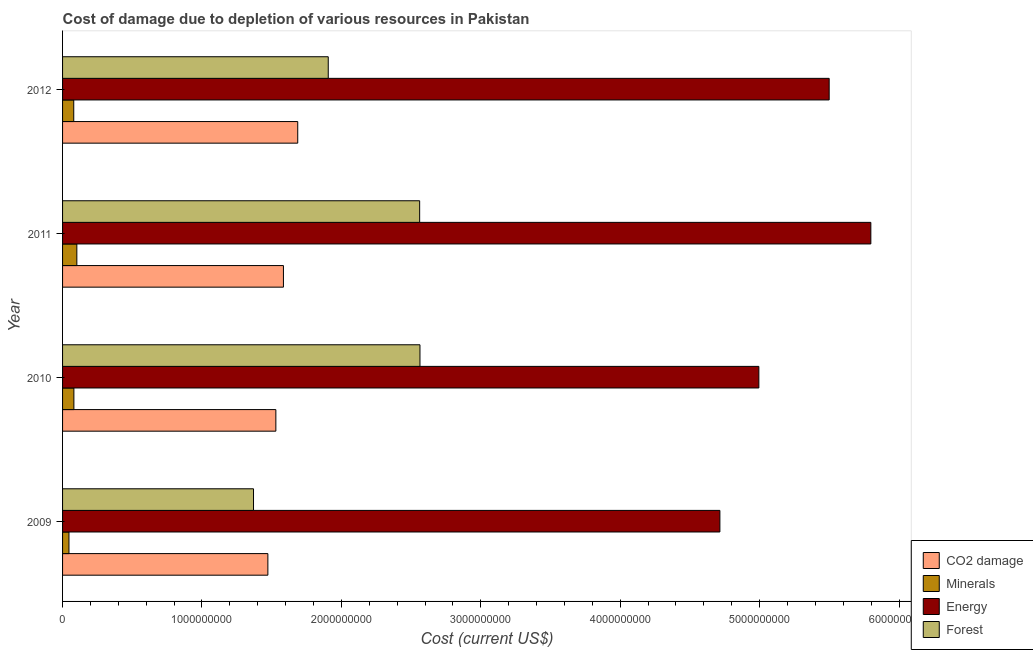How many different coloured bars are there?
Make the answer very short. 4. How many groups of bars are there?
Offer a terse response. 4. Are the number of bars on each tick of the Y-axis equal?
Your answer should be compact. Yes. How many bars are there on the 1st tick from the bottom?
Your response must be concise. 4. What is the label of the 3rd group of bars from the top?
Offer a terse response. 2010. What is the cost of damage due to depletion of energy in 2011?
Offer a terse response. 5.80e+09. Across all years, what is the maximum cost of damage due to depletion of coal?
Offer a very short reply. 1.69e+09. Across all years, what is the minimum cost of damage due to depletion of coal?
Offer a very short reply. 1.47e+09. In which year was the cost of damage due to depletion of forests maximum?
Give a very brief answer. 2010. In which year was the cost of damage due to depletion of forests minimum?
Keep it short and to the point. 2009. What is the total cost of damage due to depletion of energy in the graph?
Your answer should be compact. 2.10e+1. What is the difference between the cost of damage due to depletion of energy in 2009 and that in 2012?
Offer a very short reply. -7.84e+08. What is the difference between the cost of damage due to depletion of minerals in 2012 and the cost of damage due to depletion of energy in 2011?
Your response must be concise. -5.72e+09. What is the average cost of damage due to depletion of energy per year?
Your answer should be very brief. 5.25e+09. In the year 2009, what is the difference between the cost of damage due to depletion of forests and cost of damage due to depletion of minerals?
Provide a succinct answer. 1.32e+09. In how many years, is the cost of damage due to depletion of coal greater than 2400000000 US$?
Keep it short and to the point. 0. What is the ratio of the cost of damage due to depletion of forests in 2009 to that in 2010?
Your response must be concise. 0.53. What is the difference between the highest and the second highest cost of damage due to depletion of forests?
Your response must be concise. 2.16e+06. What is the difference between the highest and the lowest cost of damage due to depletion of coal?
Provide a succinct answer. 2.14e+08. In how many years, is the cost of damage due to depletion of minerals greater than the average cost of damage due to depletion of minerals taken over all years?
Your answer should be compact. 3. What does the 4th bar from the top in 2012 represents?
Your response must be concise. CO2 damage. What does the 4th bar from the bottom in 2012 represents?
Offer a very short reply. Forest. Is it the case that in every year, the sum of the cost of damage due to depletion of coal and cost of damage due to depletion of minerals is greater than the cost of damage due to depletion of energy?
Your response must be concise. No. What is the difference between two consecutive major ticks on the X-axis?
Ensure brevity in your answer.  1.00e+09. Are the values on the major ticks of X-axis written in scientific E-notation?
Give a very brief answer. No. Does the graph contain grids?
Give a very brief answer. No. Where does the legend appear in the graph?
Ensure brevity in your answer.  Bottom right. How many legend labels are there?
Provide a succinct answer. 4. What is the title of the graph?
Keep it short and to the point. Cost of damage due to depletion of various resources in Pakistan . Does "Australia" appear as one of the legend labels in the graph?
Offer a very short reply. No. What is the label or title of the X-axis?
Offer a terse response. Cost (current US$). What is the label or title of the Y-axis?
Offer a very short reply. Year. What is the Cost (current US$) of CO2 damage in 2009?
Give a very brief answer. 1.47e+09. What is the Cost (current US$) in Minerals in 2009?
Give a very brief answer. 4.59e+07. What is the Cost (current US$) of Energy in 2009?
Your answer should be compact. 4.72e+09. What is the Cost (current US$) of Forest in 2009?
Your response must be concise. 1.37e+09. What is the Cost (current US$) of CO2 damage in 2010?
Keep it short and to the point. 1.53e+09. What is the Cost (current US$) in Minerals in 2010?
Your response must be concise. 8.13e+07. What is the Cost (current US$) in Energy in 2010?
Your answer should be very brief. 4.99e+09. What is the Cost (current US$) of Forest in 2010?
Provide a succinct answer. 2.56e+09. What is the Cost (current US$) of CO2 damage in 2011?
Offer a very short reply. 1.58e+09. What is the Cost (current US$) in Minerals in 2011?
Provide a succinct answer. 1.02e+08. What is the Cost (current US$) of Energy in 2011?
Your answer should be very brief. 5.80e+09. What is the Cost (current US$) of Forest in 2011?
Keep it short and to the point. 2.56e+09. What is the Cost (current US$) of CO2 damage in 2012?
Ensure brevity in your answer.  1.69e+09. What is the Cost (current US$) of Minerals in 2012?
Give a very brief answer. 8.02e+07. What is the Cost (current US$) of Energy in 2012?
Ensure brevity in your answer.  5.50e+09. What is the Cost (current US$) in Forest in 2012?
Your answer should be compact. 1.91e+09. Across all years, what is the maximum Cost (current US$) in CO2 damage?
Your answer should be compact. 1.69e+09. Across all years, what is the maximum Cost (current US$) in Minerals?
Your response must be concise. 1.02e+08. Across all years, what is the maximum Cost (current US$) in Energy?
Ensure brevity in your answer.  5.80e+09. Across all years, what is the maximum Cost (current US$) of Forest?
Provide a short and direct response. 2.56e+09. Across all years, what is the minimum Cost (current US$) of CO2 damage?
Give a very brief answer. 1.47e+09. Across all years, what is the minimum Cost (current US$) of Minerals?
Provide a succinct answer. 4.59e+07. Across all years, what is the minimum Cost (current US$) of Energy?
Offer a terse response. 4.72e+09. Across all years, what is the minimum Cost (current US$) of Forest?
Provide a succinct answer. 1.37e+09. What is the total Cost (current US$) of CO2 damage in the graph?
Offer a very short reply. 6.27e+09. What is the total Cost (current US$) in Minerals in the graph?
Keep it short and to the point. 3.10e+08. What is the total Cost (current US$) of Energy in the graph?
Give a very brief answer. 2.10e+1. What is the total Cost (current US$) in Forest in the graph?
Your answer should be compact. 8.40e+09. What is the difference between the Cost (current US$) of CO2 damage in 2009 and that in 2010?
Provide a succinct answer. -5.72e+07. What is the difference between the Cost (current US$) in Minerals in 2009 and that in 2010?
Make the answer very short. -3.54e+07. What is the difference between the Cost (current US$) of Energy in 2009 and that in 2010?
Your answer should be very brief. -2.79e+08. What is the difference between the Cost (current US$) of Forest in 2009 and that in 2010?
Give a very brief answer. -1.19e+09. What is the difference between the Cost (current US$) of CO2 damage in 2009 and that in 2011?
Give a very brief answer. -1.12e+08. What is the difference between the Cost (current US$) of Minerals in 2009 and that in 2011?
Provide a short and direct response. -5.65e+07. What is the difference between the Cost (current US$) in Energy in 2009 and that in 2011?
Offer a terse response. -1.08e+09. What is the difference between the Cost (current US$) of Forest in 2009 and that in 2011?
Offer a very short reply. -1.19e+09. What is the difference between the Cost (current US$) of CO2 damage in 2009 and that in 2012?
Ensure brevity in your answer.  -2.14e+08. What is the difference between the Cost (current US$) of Minerals in 2009 and that in 2012?
Your response must be concise. -3.43e+07. What is the difference between the Cost (current US$) in Energy in 2009 and that in 2012?
Your answer should be very brief. -7.84e+08. What is the difference between the Cost (current US$) of Forest in 2009 and that in 2012?
Give a very brief answer. -5.36e+08. What is the difference between the Cost (current US$) in CO2 damage in 2010 and that in 2011?
Make the answer very short. -5.44e+07. What is the difference between the Cost (current US$) of Minerals in 2010 and that in 2011?
Provide a succinct answer. -2.11e+07. What is the difference between the Cost (current US$) in Energy in 2010 and that in 2011?
Provide a short and direct response. -8.03e+08. What is the difference between the Cost (current US$) of Forest in 2010 and that in 2011?
Your response must be concise. 2.16e+06. What is the difference between the Cost (current US$) in CO2 damage in 2010 and that in 2012?
Provide a succinct answer. -1.57e+08. What is the difference between the Cost (current US$) of Minerals in 2010 and that in 2012?
Provide a succinct answer. 1.03e+06. What is the difference between the Cost (current US$) of Energy in 2010 and that in 2012?
Your response must be concise. -5.04e+08. What is the difference between the Cost (current US$) in Forest in 2010 and that in 2012?
Ensure brevity in your answer.  6.58e+08. What is the difference between the Cost (current US$) in CO2 damage in 2011 and that in 2012?
Provide a succinct answer. -1.03e+08. What is the difference between the Cost (current US$) of Minerals in 2011 and that in 2012?
Make the answer very short. 2.22e+07. What is the difference between the Cost (current US$) of Energy in 2011 and that in 2012?
Provide a short and direct response. 2.99e+08. What is the difference between the Cost (current US$) of Forest in 2011 and that in 2012?
Give a very brief answer. 6.56e+08. What is the difference between the Cost (current US$) in CO2 damage in 2009 and the Cost (current US$) in Minerals in 2010?
Give a very brief answer. 1.39e+09. What is the difference between the Cost (current US$) in CO2 damage in 2009 and the Cost (current US$) in Energy in 2010?
Your answer should be compact. -3.52e+09. What is the difference between the Cost (current US$) in CO2 damage in 2009 and the Cost (current US$) in Forest in 2010?
Your answer should be compact. -1.09e+09. What is the difference between the Cost (current US$) of Minerals in 2009 and the Cost (current US$) of Energy in 2010?
Give a very brief answer. -4.95e+09. What is the difference between the Cost (current US$) in Minerals in 2009 and the Cost (current US$) in Forest in 2010?
Your answer should be very brief. -2.52e+09. What is the difference between the Cost (current US$) in Energy in 2009 and the Cost (current US$) in Forest in 2010?
Give a very brief answer. 2.15e+09. What is the difference between the Cost (current US$) in CO2 damage in 2009 and the Cost (current US$) in Minerals in 2011?
Provide a succinct answer. 1.37e+09. What is the difference between the Cost (current US$) of CO2 damage in 2009 and the Cost (current US$) of Energy in 2011?
Your response must be concise. -4.33e+09. What is the difference between the Cost (current US$) in CO2 damage in 2009 and the Cost (current US$) in Forest in 2011?
Your answer should be very brief. -1.09e+09. What is the difference between the Cost (current US$) in Minerals in 2009 and the Cost (current US$) in Energy in 2011?
Provide a short and direct response. -5.75e+09. What is the difference between the Cost (current US$) in Minerals in 2009 and the Cost (current US$) in Forest in 2011?
Your answer should be compact. -2.52e+09. What is the difference between the Cost (current US$) of Energy in 2009 and the Cost (current US$) of Forest in 2011?
Your response must be concise. 2.15e+09. What is the difference between the Cost (current US$) of CO2 damage in 2009 and the Cost (current US$) of Minerals in 2012?
Provide a succinct answer. 1.39e+09. What is the difference between the Cost (current US$) in CO2 damage in 2009 and the Cost (current US$) in Energy in 2012?
Provide a succinct answer. -4.03e+09. What is the difference between the Cost (current US$) of CO2 damage in 2009 and the Cost (current US$) of Forest in 2012?
Your answer should be very brief. -4.33e+08. What is the difference between the Cost (current US$) of Minerals in 2009 and the Cost (current US$) of Energy in 2012?
Your answer should be very brief. -5.45e+09. What is the difference between the Cost (current US$) in Minerals in 2009 and the Cost (current US$) in Forest in 2012?
Your answer should be compact. -1.86e+09. What is the difference between the Cost (current US$) of Energy in 2009 and the Cost (current US$) of Forest in 2012?
Give a very brief answer. 2.81e+09. What is the difference between the Cost (current US$) in CO2 damage in 2010 and the Cost (current US$) in Minerals in 2011?
Keep it short and to the point. 1.43e+09. What is the difference between the Cost (current US$) of CO2 damage in 2010 and the Cost (current US$) of Energy in 2011?
Keep it short and to the point. -4.27e+09. What is the difference between the Cost (current US$) in CO2 damage in 2010 and the Cost (current US$) in Forest in 2011?
Your answer should be compact. -1.03e+09. What is the difference between the Cost (current US$) of Minerals in 2010 and the Cost (current US$) of Energy in 2011?
Your answer should be very brief. -5.72e+09. What is the difference between the Cost (current US$) of Minerals in 2010 and the Cost (current US$) of Forest in 2011?
Offer a very short reply. -2.48e+09. What is the difference between the Cost (current US$) in Energy in 2010 and the Cost (current US$) in Forest in 2011?
Make the answer very short. 2.43e+09. What is the difference between the Cost (current US$) of CO2 damage in 2010 and the Cost (current US$) of Minerals in 2012?
Give a very brief answer. 1.45e+09. What is the difference between the Cost (current US$) in CO2 damage in 2010 and the Cost (current US$) in Energy in 2012?
Make the answer very short. -3.97e+09. What is the difference between the Cost (current US$) of CO2 damage in 2010 and the Cost (current US$) of Forest in 2012?
Give a very brief answer. -3.76e+08. What is the difference between the Cost (current US$) of Minerals in 2010 and the Cost (current US$) of Energy in 2012?
Provide a succinct answer. -5.42e+09. What is the difference between the Cost (current US$) of Minerals in 2010 and the Cost (current US$) of Forest in 2012?
Make the answer very short. -1.82e+09. What is the difference between the Cost (current US$) in Energy in 2010 and the Cost (current US$) in Forest in 2012?
Offer a terse response. 3.09e+09. What is the difference between the Cost (current US$) in CO2 damage in 2011 and the Cost (current US$) in Minerals in 2012?
Offer a terse response. 1.50e+09. What is the difference between the Cost (current US$) of CO2 damage in 2011 and the Cost (current US$) of Energy in 2012?
Offer a terse response. -3.91e+09. What is the difference between the Cost (current US$) in CO2 damage in 2011 and the Cost (current US$) in Forest in 2012?
Give a very brief answer. -3.21e+08. What is the difference between the Cost (current US$) of Minerals in 2011 and the Cost (current US$) of Energy in 2012?
Your answer should be compact. -5.40e+09. What is the difference between the Cost (current US$) in Minerals in 2011 and the Cost (current US$) in Forest in 2012?
Your answer should be compact. -1.80e+09. What is the difference between the Cost (current US$) of Energy in 2011 and the Cost (current US$) of Forest in 2012?
Offer a terse response. 3.89e+09. What is the average Cost (current US$) in CO2 damage per year?
Give a very brief answer. 1.57e+09. What is the average Cost (current US$) of Minerals per year?
Offer a very short reply. 7.74e+07. What is the average Cost (current US$) in Energy per year?
Give a very brief answer. 5.25e+09. What is the average Cost (current US$) of Forest per year?
Your answer should be very brief. 2.10e+09. In the year 2009, what is the difference between the Cost (current US$) in CO2 damage and Cost (current US$) in Minerals?
Give a very brief answer. 1.43e+09. In the year 2009, what is the difference between the Cost (current US$) in CO2 damage and Cost (current US$) in Energy?
Your response must be concise. -3.24e+09. In the year 2009, what is the difference between the Cost (current US$) in CO2 damage and Cost (current US$) in Forest?
Ensure brevity in your answer.  1.03e+08. In the year 2009, what is the difference between the Cost (current US$) of Minerals and Cost (current US$) of Energy?
Your response must be concise. -4.67e+09. In the year 2009, what is the difference between the Cost (current US$) of Minerals and Cost (current US$) of Forest?
Ensure brevity in your answer.  -1.32e+09. In the year 2009, what is the difference between the Cost (current US$) of Energy and Cost (current US$) of Forest?
Give a very brief answer. 3.35e+09. In the year 2010, what is the difference between the Cost (current US$) in CO2 damage and Cost (current US$) in Minerals?
Keep it short and to the point. 1.45e+09. In the year 2010, what is the difference between the Cost (current US$) of CO2 damage and Cost (current US$) of Energy?
Offer a terse response. -3.46e+09. In the year 2010, what is the difference between the Cost (current US$) in CO2 damage and Cost (current US$) in Forest?
Keep it short and to the point. -1.03e+09. In the year 2010, what is the difference between the Cost (current US$) of Minerals and Cost (current US$) of Energy?
Keep it short and to the point. -4.91e+09. In the year 2010, what is the difference between the Cost (current US$) of Minerals and Cost (current US$) of Forest?
Make the answer very short. -2.48e+09. In the year 2010, what is the difference between the Cost (current US$) of Energy and Cost (current US$) of Forest?
Make the answer very short. 2.43e+09. In the year 2011, what is the difference between the Cost (current US$) of CO2 damage and Cost (current US$) of Minerals?
Make the answer very short. 1.48e+09. In the year 2011, what is the difference between the Cost (current US$) in CO2 damage and Cost (current US$) in Energy?
Give a very brief answer. -4.21e+09. In the year 2011, what is the difference between the Cost (current US$) in CO2 damage and Cost (current US$) in Forest?
Provide a short and direct response. -9.77e+08. In the year 2011, what is the difference between the Cost (current US$) in Minerals and Cost (current US$) in Energy?
Make the answer very short. -5.70e+09. In the year 2011, what is the difference between the Cost (current US$) of Minerals and Cost (current US$) of Forest?
Your answer should be very brief. -2.46e+09. In the year 2011, what is the difference between the Cost (current US$) in Energy and Cost (current US$) in Forest?
Offer a terse response. 3.24e+09. In the year 2012, what is the difference between the Cost (current US$) of CO2 damage and Cost (current US$) of Minerals?
Offer a terse response. 1.61e+09. In the year 2012, what is the difference between the Cost (current US$) in CO2 damage and Cost (current US$) in Energy?
Ensure brevity in your answer.  -3.81e+09. In the year 2012, what is the difference between the Cost (current US$) of CO2 damage and Cost (current US$) of Forest?
Provide a short and direct response. -2.19e+08. In the year 2012, what is the difference between the Cost (current US$) in Minerals and Cost (current US$) in Energy?
Ensure brevity in your answer.  -5.42e+09. In the year 2012, what is the difference between the Cost (current US$) in Minerals and Cost (current US$) in Forest?
Offer a terse response. -1.83e+09. In the year 2012, what is the difference between the Cost (current US$) of Energy and Cost (current US$) of Forest?
Provide a short and direct response. 3.59e+09. What is the ratio of the Cost (current US$) of CO2 damage in 2009 to that in 2010?
Keep it short and to the point. 0.96. What is the ratio of the Cost (current US$) of Minerals in 2009 to that in 2010?
Your response must be concise. 0.56. What is the ratio of the Cost (current US$) of Energy in 2009 to that in 2010?
Offer a terse response. 0.94. What is the ratio of the Cost (current US$) in Forest in 2009 to that in 2010?
Provide a succinct answer. 0.53. What is the ratio of the Cost (current US$) of CO2 damage in 2009 to that in 2011?
Provide a succinct answer. 0.93. What is the ratio of the Cost (current US$) of Minerals in 2009 to that in 2011?
Your answer should be compact. 0.45. What is the ratio of the Cost (current US$) of Energy in 2009 to that in 2011?
Your answer should be very brief. 0.81. What is the ratio of the Cost (current US$) in Forest in 2009 to that in 2011?
Make the answer very short. 0.53. What is the ratio of the Cost (current US$) of CO2 damage in 2009 to that in 2012?
Your response must be concise. 0.87. What is the ratio of the Cost (current US$) of Minerals in 2009 to that in 2012?
Keep it short and to the point. 0.57. What is the ratio of the Cost (current US$) in Energy in 2009 to that in 2012?
Make the answer very short. 0.86. What is the ratio of the Cost (current US$) in Forest in 2009 to that in 2012?
Offer a terse response. 0.72. What is the ratio of the Cost (current US$) in CO2 damage in 2010 to that in 2011?
Provide a short and direct response. 0.97. What is the ratio of the Cost (current US$) of Minerals in 2010 to that in 2011?
Your answer should be compact. 0.79. What is the ratio of the Cost (current US$) of Energy in 2010 to that in 2011?
Ensure brevity in your answer.  0.86. What is the ratio of the Cost (current US$) in Forest in 2010 to that in 2011?
Your answer should be very brief. 1. What is the ratio of the Cost (current US$) in CO2 damage in 2010 to that in 2012?
Your answer should be compact. 0.91. What is the ratio of the Cost (current US$) of Minerals in 2010 to that in 2012?
Keep it short and to the point. 1.01. What is the ratio of the Cost (current US$) of Energy in 2010 to that in 2012?
Provide a succinct answer. 0.91. What is the ratio of the Cost (current US$) in Forest in 2010 to that in 2012?
Make the answer very short. 1.35. What is the ratio of the Cost (current US$) in CO2 damage in 2011 to that in 2012?
Your answer should be very brief. 0.94. What is the ratio of the Cost (current US$) of Minerals in 2011 to that in 2012?
Make the answer very short. 1.28. What is the ratio of the Cost (current US$) in Energy in 2011 to that in 2012?
Your response must be concise. 1.05. What is the ratio of the Cost (current US$) in Forest in 2011 to that in 2012?
Offer a very short reply. 1.34. What is the difference between the highest and the second highest Cost (current US$) in CO2 damage?
Give a very brief answer. 1.03e+08. What is the difference between the highest and the second highest Cost (current US$) in Minerals?
Keep it short and to the point. 2.11e+07. What is the difference between the highest and the second highest Cost (current US$) of Energy?
Ensure brevity in your answer.  2.99e+08. What is the difference between the highest and the second highest Cost (current US$) of Forest?
Your answer should be compact. 2.16e+06. What is the difference between the highest and the lowest Cost (current US$) of CO2 damage?
Provide a succinct answer. 2.14e+08. What is the difference between the highest and the lowest Cost (current US$) of Minerals?
Provide a short and direct response. 5.65e+07. What is the difference between the highest and the lowest Cost (current US$) of Energy?
Your answer should be very brief. 1.08e+09. What is the difference between the highest and the lowest Cost (current US$) in Forest?
Keep it short and to the point. 1.19e+09. 